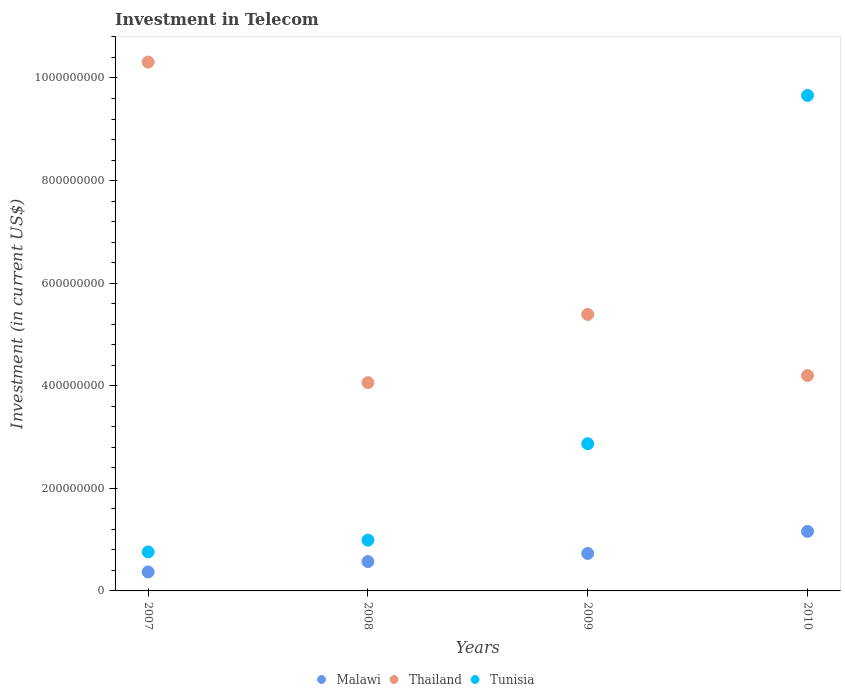How many different coloured dotlines are there?
Your response must be concise. 3. Is the number of dotlines equal to the number of legend labels?
Your answer should be compact. Yes. What is the amount invested in telecom in Malawi in 2009?
Your response must be concise. 7.30e+07. Across all years, what is the maximum amount invested in telecom in Malawi?
Your answer should be compact. 1.16e+08. Across all years, what is the minimum amount invested in telecom in Malawi?
Your response must be concise. 3.70e+07. In which year was the amount invested in telecom in Tunisia minimum?
Provide a succinct answer. 2007. What is the total amount invested in telecom in Malawi in the graph?
Give a very brief answer. 2.83e+08. What is the difference between the amount invested in telecom in Malawi in 2007 and that in 2010?
Ensure brevity in your answer.  -7.90e+07. What is the difference between the amount invested in telecom in Thailand in 2010 and the amount invested in telecom in Malawi in 2007?
Provide a succinct answer. 3.83e+08. What is the average amount invested in telecom in Malawi per year?
Provide a short and direct response. 7.08e+07. In the year 2007, what is the difference between the amount invested in telecom in Malawi and amount invested in telecom in Thailand?
Your answer should be very brief. -9.94e+08. In how many years, is the amount invested in telecom in Thailand greater than 560000000 US$?
Your answer should be very brief. 1. What is the ratio of the amount invested in telecom in Tunisia in 2007 to that in 2009?
Keep it short and to the point. 0.26. What is the difference between the highest and the second highest amount invested in telecom in Malawi?
Your response must be concise. 4.30e+07. What is the difference between the highest and the lowest amount invested in telecom in Tunisia?
Offer a very short reply. 8.90e+08. In how many years, is the amount invested in telecom in Malawi greater than the average amount invested in telecom in Malawi taken over all years?
Provide a succinct answer. 2. Is the sum of the amount invested in telecom in Malawi in 2008 and 2009 greater than the maximum amount invested in telecom in Thailand across all years?
Your answer should be very brief. No. Is it the case that in every year, the sum of the amount invested in telecom in Thailand and amount invested in telecom in Malawi  is greater than the amount invested in telecom in Tunisia?
Keep it short and to the point. No. Does the amount invested in telecom in Tunisia monotonically increase over the years?
Provide a short and direct response. Yes. How many dotlines are there?
Offer a terse response. 3. How many years are there in the graph?
Offer a very short reply. 4. Does the graph contain any zero values?
Your response must be concise. No. Where does the legend appear in the graph?
Keep it short and to the point. Bottom center. How many legend labels are there?
Offer a very short reply. 3. What is the title of the graph?
Keep it short and to the point. Investment in Telecom. What is the label or title of the Y-axis?
Give a very brief answer. Investment (in current US$). What is the Investment (in current US$) of Malawi in 2007?
Provide a short and direct response. 3.70e+07. What is the Investment (in current US$) in Thailand in 2007?
Offer a very short reply. 1.03e+09. What is the Investment (in current US$) of Tunisia in 2007?
Keep it short and to the point. 7.60e+07. What is the Investment (in current US$) of Malawi in 2008?
Your answer should be very brief. 5.72e+07. What is the Investment (in current US$) of Thailand in 2008?
Keep it short and to the point. 4.06e+08. What is the Investment (in current US$) of Tunisia in 2008?
Make the answer very short. 9.90e+07. What is the Investment (in current US$) in Malawi in 2009?
Make the answer very short. 7.30e+07. What is the Investment (in current US$) in Thailand in 2009?
Ensure brevity in your answer.  5.39e+08. What is the Investment (in current US$) of Tunisia in 2009?
Your answer should be compact. 2.87e+08. What is the Investment (in current US$) in Malawi in 2010?
Offer a terse response. 1.16e+08. What is the Investment (in current US$) of Thailand in 2010?
Provide a short and direct response. 4.20e+08. What is the Investment (in current US$) of Tunisia in 2010?
Your answer should be very brief. 9.66e+08. Across all years, what is the maximum Investment (in current US$) in Malawi?
Offer a very short reply. 1.16e+08. Across all years, what is the maximum Investment (in current US$) of Thailand?
Your answer should be compact. 1.03e+09. Across all years, what is the maximum Investment (in current US$) in Tunisia?
Provide a succinct answer. 9.66e+08. Across all years, what is the minimum Investment (in current US$) of Malawi?
Provide a short and direct response. 3.70e+07. Across all years, what is the minimum Investment (in current US$) of Thailand?
Provide a short and direct response. 4.06e+08. Across all years, what is the minimum Investment (in current US$) in Tunisia?
Make the answer very short. 7.60e+07. What is the total Investment (in current US$) in Malawi in the graph?
Your answer should be very brief. 2.83e+08. What is the total Investment (in current US$) in Thailand in the graph?
Offer a very short reply. 2.40e+09. What is the total Investment (in current US$) of Tunisia in the graph?
Your answer should be compact. 1.43e+09. What is the difference between the Investment (in current US$) of Malawi in 2007 and that in 2008?
Ensure brevity in your answer.  -2.02e+07. What is the difference between the Investment (in current US$) in Thailand in 2007 and that in 2008?
Give a very brief answer. 6.25e+08. What is the difference between the Investment (in current US$) of Tunisia in 2007 and that in 2008?
Offer a very short reply. -2.30e+07. What is the difference between the Investment (in current US$) in Malawi in 2007 and that in 2009?
Offer a terse response. -3.60e+07. What is the difference between the Investment (in current US$) in Thailand in 2007 and that in 2009?
Your answer should be very brief. 4.92e+08. What is the difference between the Investment (in current US$) in Tunisia in 2007 and that in 2009?
Offer a terse response. -2.11e+08. What is the difference between the Investment (in current US$) in Malawi in 2007 and that in 2010?
Your answer should be very brief. -7.90e+07. What is the difference between the Investment (in current US$) in Thailand in 2007 and that in 2010?
Provide a succinct answer. 6.11e+08. What is the difference between the Investment (in current US$) of Tunisia in 2007 and that in 2010?
Ensure brevity in your answer.  -8.90e+08. What is the difference between the Investment (in current US$) in Malawi in 2008 and that in 2009?
Offer a terse response. -1.58e+07. What is the difference between the Investment (in current US$) in Thailand in 2008 and that in 2009?
Your response must be concise. -1.33e+08. What is the difference between the Investment (in current US$) in Tunisia in 2008 and that in 2009?
Provide a short and direct response. -1.88e+08. What is the difference between the Investment (in current US$) of Malawi in 2008 and that in 2010?
Your response must be concise. -5.88e+07. What is the difference between the Investment (in current US$) of Thailand in 2008 and that in 2010?
Give a very brief answer. -1.40e+07. What is the difference between the Investment (in current US$) of Tunisia in 2008 and that in 2010?
Make the answer very short. -8.67e+08. What is the difference between the Investment (in current US$) in Malawi in 2009 and that in 2010?
Ensure brevity in your answer.  -4.30e+07. What is the difference between the Investment (in current US$) of Thailand in 2009 and that in 2010?
Keep it short and to the point. 1.19e+08. What is the difference between the Investment (in current US$) of Tunisia in 2009 and that in 2010?
Your answer should be compact. -6.79e+08. What is the difference between the Investment (in current US$) of Malawi in 2007 and the Investment (in current US$) of Thailand in 2008?
Provide a succinct answer. -3.69e+08. What is the difference between the Investment (in current US$) of Malawi in 2007 and the Investment (in current US$) of Tunisia in 2008?
Offer a terse response. -6.20e+07. What is the difference between the Investment (in current US$) in Thailand in 2007 and the Investment (in current US$) in Tunisia in 2008?
Keep it short and to the point. 9.32e+08. What is the difference between the Investment (in current US$) of Malawi in 2007 and the Investment (in current US$) of Thailand in 2009?
Your response must be concise. -5.02e+08. What is the difference between the Investment (in current US$) of Malawi in 2007 and the Investment (in current US$) of Tunisia in 2009?
Keep it short and to the point. -2.50e+08. What is the difference between the Investment (in current US$) in Thailand in 2007 and the Investment (in current US$) in Tunisia in 2009?
Your answer should be compact. 7.44e+08. What is the difference between the Investment (in current US$) of Malawi in 2007 and the Investment (in current US$) of Thailand in 2010?
Offer a terse response. -3.83e+08. What is the difference between the Investment (in current US$) of Malawi in 2007 and the Investment (in current US$) of Tunisia in 2010?
Your answer should be compact. -9.29e+08. What is the difference between the Investment (in current US$) in Thailand in 2007 and the Investment (in current US$) in Tunisia in 2010?
Your answer should be compact. 6.50e+07. What is the difference between the Investment (in current US$) of Malawi in 2008 and the Investment (in current US$) of Thailand in 2009?
Offer a terse response. -4.82e+08. What is the difference between the Investment (in current US$) of Malawi in 2008 and the Investment (in current US$) of Tunisia in 2009?
Provide a succinct answer. -2.30e+08. What is the difference between the Investment (in current US$) of Thailand in 2008 and the Investment (in current US$) of Tunisia in 2009?
Provide a succinct answer. 1.19e+08. What is the difference between the Investment (in current US$) in Malawi in 2008 and the Investment (in current US$) in Thailand in 2010?
Offer a terse response. -3.63e+08. What is the difference between the Investment (in current US$) of Malawi in 2008 and the Investment (in current US$) of Tunisia in 2010?
Give a very brief answer. -9.09e+08. What is the difference between the Investment (in current US$) in Thailand in 2008 and the Investment (in current US$) in Tunisia in 2010?
Your response must be concise. -5.60e+08. What is the difference between the Investment (in current US$) in Malawi in 2009 and the Investment (in current US$) in Thailand in 2010?
Provide a succinct answer. -3.47e+08. What is the difference between the Investment (in current US$) in Malawi in 2009 and the Investment (in current US$) in Tunisia in 2010?
Provide a succinct answer. -8.93e+08. What is the difference between the Investment (in current US$) of Thailand in 2009 and the Investment (in current US$) of Tunisia in 2010?
Make the answer very short. -4.27e+08. What is the average Investment (in current US$) in Malawi per year?
Provide a short and direct response. 7.08e+07. What is the average Investment (in current US$) of Thailand per year?
Give a very brief answer. 5.99e+08. What is the average Investment (in current US$) of Tunisia per year?
Provide a succinct answer. 3.57e+08. In the year 2007, what is the difference between the Investment (in current US$) in Malawi and Investment (in current US$) in Thailand?
Offer a very short reply. -9.94e+08. In the year 2007, what is the difference between the Investment (in current US$) of Malawi and Investment (in current US$) of Tunisia?
Offer a very short reply. -3.90e+07. In the year 2007, what is the difference between the Investment (in current US$) of Thailand and Investment (in current US$) of Tunisia?
Your answer should be very brief. 9.55e+08. In the year 2008, what is the difference between the Investment (in current US$) in Malawi and Investment (in current US$) in Thailand?
Your answer should be very brief. -3.49e+08. In the year 2008, what is the difference between the Investment (in current US$) in Malawi and Investment (in current US$) in Tunisia?
Provide a short and direct response. -4.18e+07. In the year 2008, what is the difference between the Investment (in current US$) of Thailand and Investment (in current US$) of Tunisia?
Your answer should be compact. 3.07e+08. In the year 2009, what is the difference between the Investment (in current US$) of Malawi and Investment (in current US$) of Thailand?
Your answer should be very brief. -4.66e+08. In the year 2009, what is the difference between the Investment (in current US$) of Malawi and Investment (in current US$) of Tunisia?
Ensure brevity in your answer.  -2.14e+08. In the year 2009, what is the difference between the Investment (in current US$) in Thailand and Investment (in current US$) in Tunisia?
Give a very brief answer. 2.52e+08. In the year 2010, what is the difference between the Investment (in current US$) in Malawi and Investment (in current US$) in Thailand?
Provide a succinct answer. -3.04e+08. In the year 2010, what is the difference between the Investment (in current US$) of Malawi and Investment (in current US$) of Tunisia?
Your answer should be compact. -8.50e+08. In the year 2010, what is the difference between the Investment (in current US$) of Thailand and Investment (in current US$) of Tunisia?
Your answer should be compact. -5.46e+08. What is the ratio of the Investment (in current US$) in Malawi in 2007 to that in 2008?
Make the answer very short. 0.65. What is the ratio of the Investment (in current US$) of Thailand in 2007 to that in 2008?
Ensure brevity in your answer.  2.54. What is the ratio of the Investment (in current US$) in Tunisia in 2007 to that in 2008?
Offer a very short reply. 0.77. What is the ratio of the Investment (in current US$) of Malawi in 2007 to that in 2009?
Give a very brief answer. 0.51. What is the ratio of the Investment (in current US$) in Thailand in 2007 to that in 2009?
Provide a succinct answer. 1.91. What is the ratio of the Investment (in current US$) of Tunisia in 2007 to that in 2009?
Make the answer very short. 0.26. What is the ratio of the Investment (in current US$) of Malawi in 2007 to that in 2010?
Provide a succinct answer. 0.32. What is the ratio of the Investment (in current US$) of Thailand in 2007 to that in 2010?
Give a very brief answer. 2.45. What is the ratio of the Investment (in current US$) in Tunisia in 2007 to that in 2010?
Your answer should be compact. 0.08. What is the ratio of the Investment (in current US$) in Malawi in 2008 to that in 2009?
Provide a short and direct response. 0.78. What is the ratio of the Investment (in current US$) in Thailand in 2008 to that in 2009?
Make the answer very short. 0.75. What is the ratio of the Investment (in current US$) of Tunisia in 2008 to that in 2009?
Provide a succinct answer. 0.34. What is the ratio of the Investment (in current US$) in Malawi in 2008 to that in 2010?
Your response must be concise. 0.49. What is the ratio of the Investment (in current US$) in Thailand in 2008 to that in 2010?
Your response must be concise. 0.97. What is the ratio of the Investment (in current US$) in Tunisia in 2008 to that in 2010?
Keep it short and to the point. 0.1. What is the ratio of the Investment (in current US$) in Malawi in 2009 to that in 2010?
Keep it short and to the point. 0.63. What is the ratio of the Investment (in current US$) in Thailand in 2009 to that in 2010?
Your answer should be very brief. 1.28. What is the ratio of the Investment (in current US$) of Tunisia in 2009 to that in 2010?
Give a very brief answer. 0.3. What is the difference between the highest and the second highest Investment (in current US$) in Malawi?
Your answer should be compact. 4.30e+07. What is the difference between the highest and the second highest Investment (in current US$) in Thailand?
Provide a succinct answer. 4.92e+08. What is the difference between the highest and the second highest Investment (in current US$) in Tunisia?
Your answer should be very brief. 6.79e+08. What is the difference between the highest and the lowest Investment (in current US$) in Malawi?
Give a very brief answer. 7.90e+07. What is the difference between the highest and the lowest Investment (in current US$) of Thailand?
Provide a short and direct response. 6.25e+08. What is the difference between the highest and the lowest Investment (in current US$) of Tunisia?
Provide a succinct answer. 8.90e+08. 